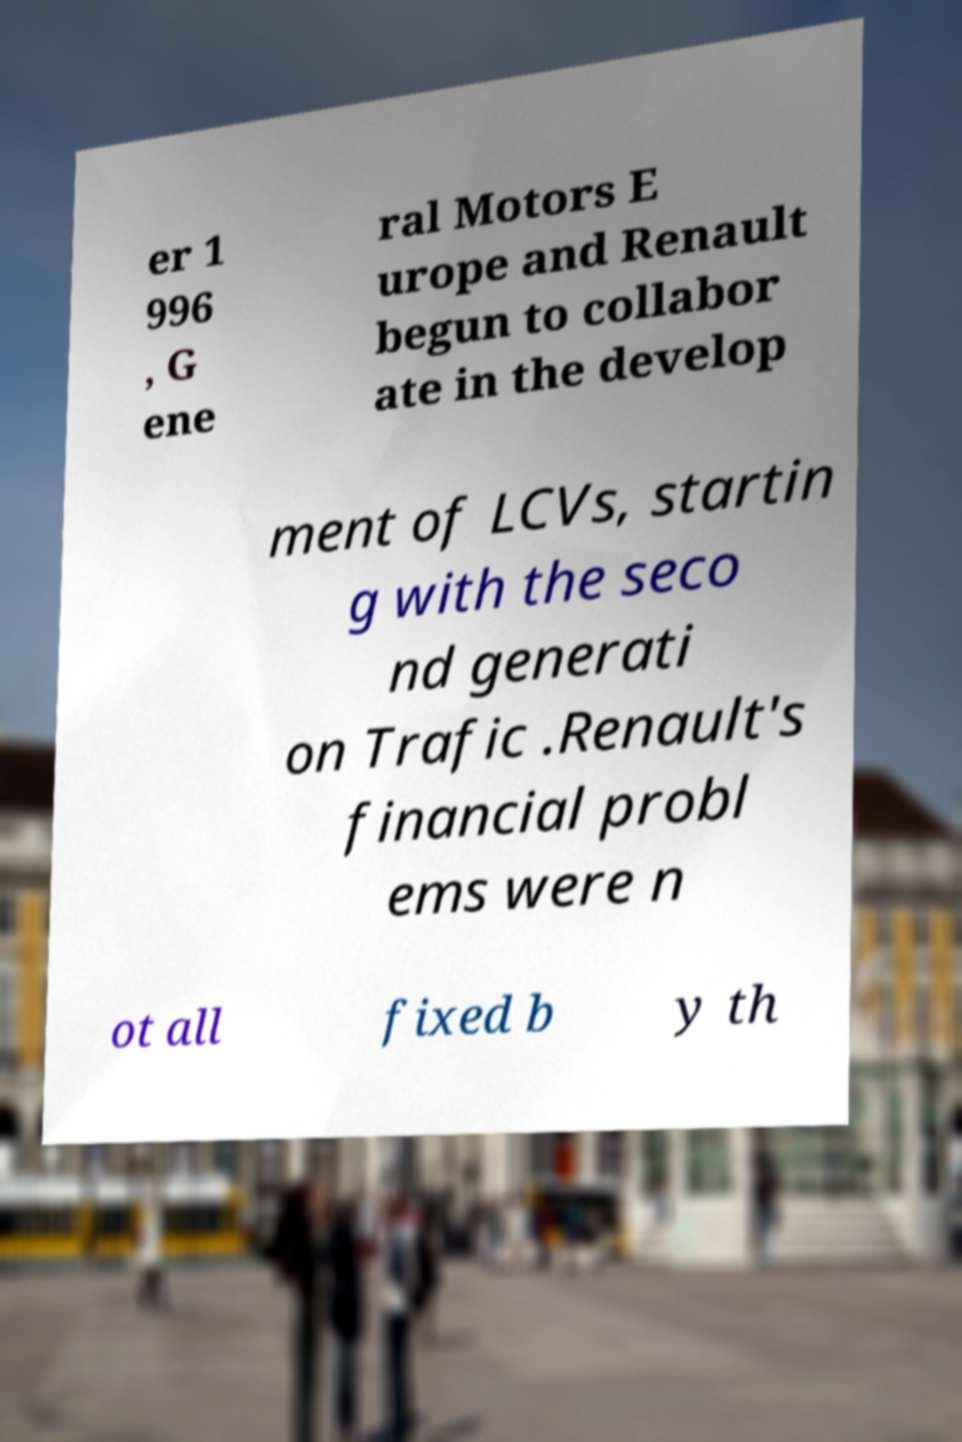Please identify and transcribe the text found in this image. er 1 996 , G ene ral Motors E urope and Renault begun to collabor ate in the develop ment of LCVs, startin g with the seco nd generati on Trafic .Renault's financial probl ems were n ot all fixed b y th 